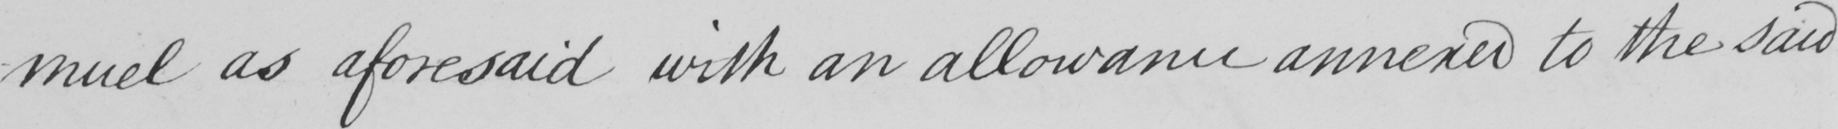Can you tell me what this handwritten text says? -muel as aforesaid with an allowance annexed to the said 